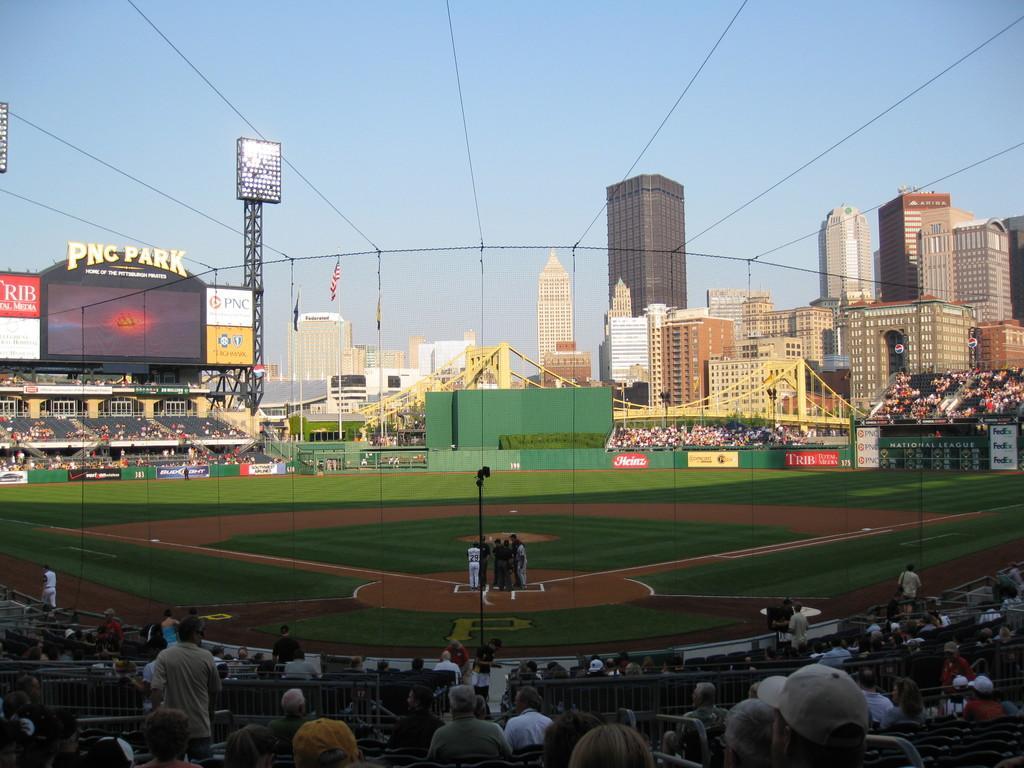In one or two sentences, can you explain what this image depicts? In this image we can see playground. Around the playground people are sitting and watching. Background of the image buildings, lights and screen are present. Top of the image sky is there. 